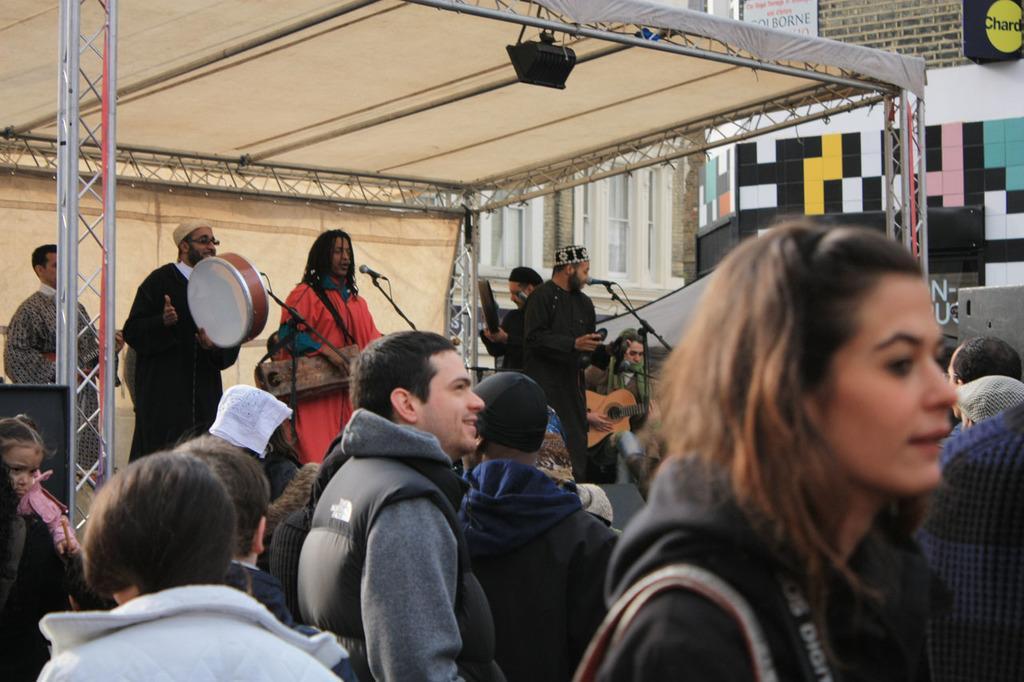How would you summarize this image in a sentence or two? In the foreground of this picture we can see the group of persons. In the center we can see the group of persons, standing, playing musical instrument and we can see the microphones are attached to the metal stands. At the top we can see a focusing light hanging on the metal rod and we can see a tent, metal rods, speakers and some other objects. In the background we can see the buildings and the text on the boards attached to the buildings. 